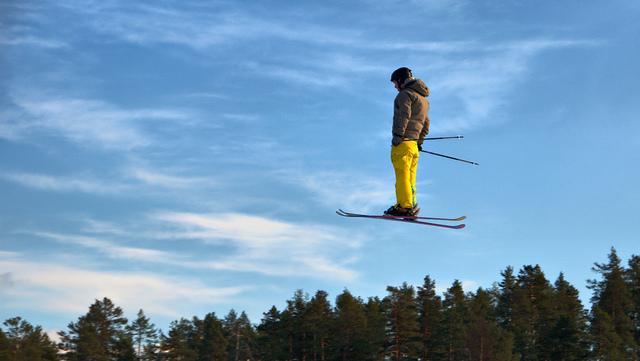Is the man skiing?
Concise answer only. Yes. Is the man doing a trick?
Keep it brief. No. What color is the man wearing?
Answer briefly. Yellow. 